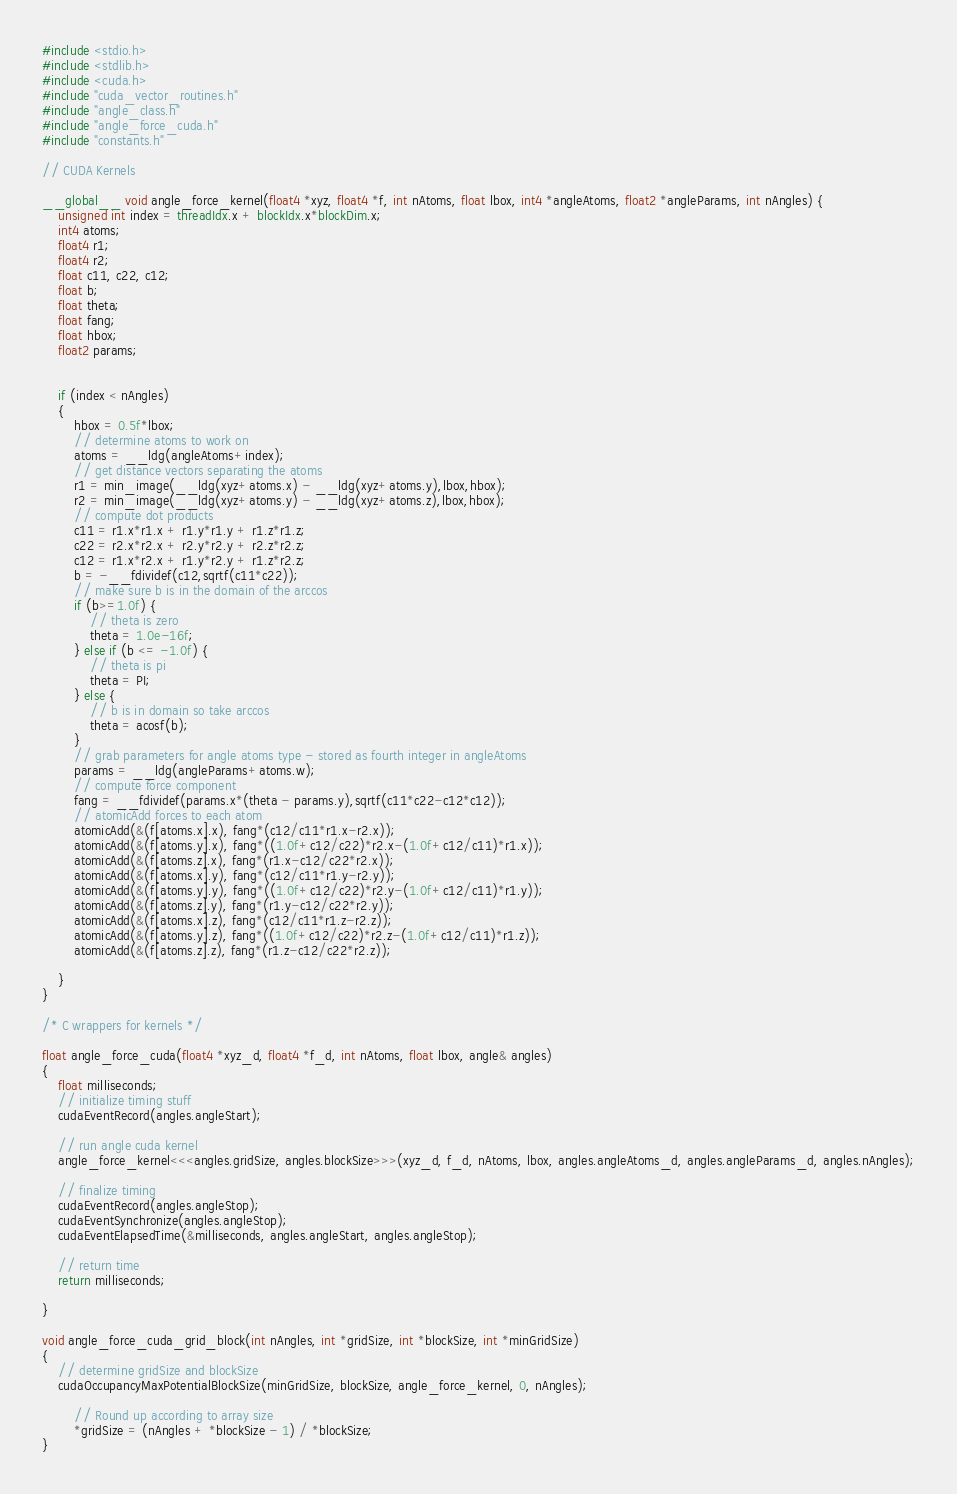Convert code to text. <code><loc_0><loc_0><loc_500><loc_500><_Cuda_>
#include <stdio.h>
#include <stdlib.h>
#include <cuda.h>
#include "cuda_vector_routines.h"
#include "angle_class.h"
#include "angle_force_cuda.h"
#include "constants.h"

// CUDA Kernels

__global__ void angle_force_kernel(float4 *xyz, float4 *f, int nAtoms, float lbox, int4 *angleAtoms, float2 *angleParams, int nAngles) {
	unsigned int index = threadIdx.x + blockIdx.x*blockDim.x;
	int4 atoms;
	float4 r1;
	float4 r2;
	float c11, c22, c12;
	float b;
	float theta;
	float fang;
	float hbox;
	float2 params;
	

	if (index < nAngles)
	{
		hbox = 0.5f*lbox;
		// determine atoms to work on
		atoms = __ldg(angleAtoms+index);
		// get distance vectors separating the atoms
		r1 = min_image(__ldg(xyz+atoms.x) - __ldg(xyz+atoms.y),lbox,hbox);
		r2 = min_image(__ldg(xyz+atoms.y) - __ldg(xyz+atoms.z),lbox,hbox);
		// compute dot products
		c11 = r1.x*r1.x + r1.y*r1.y + r1.z*r1.z;
		c22 = r2.x*r2.x + r2.y*r2.y + r2.z*r2.z;
		c12 = r1.x*r2.x + r1.y*r2.y + r1.z*r2.z;
		b = -__fdividef(c12,sqrtf(c11*c22));
		// make sure b is in the domain of the arccos
		if (b>=1.0f) {
			// theta is zero
			theta = 1.0e-16f;
		} else if (b <= -1.0f) {
			// theta is pi
			theta = PI;
		} else {
			// b is in domain so take arccos
			theta = acosf(b);
		}
		// grab parameters for angle atoms type - stored as fourth integer in angleAtoms
		params = __ldg(angleParams+atoms.w);
		// compute force component
		fang = __fdividef(params.x*(theta - params.y),sqrtf(c11*c22-c12*c12));
		// atomicAdd forces to each atom
		atomicAdd(&(f[atoms.x].x), fang*(c12/c11*r1.x-r2.x));
		atomicAdd(&(f[atoms.y].x), fang*((1.0f+c12/c22)*r2.x-(1.0f+c12/c11)*r1.x));
		atomicAdd(&(f[atoms.z].x), fang*(r1.x-c12/c22*r2.x));
		atomicAdd(&(f[atoms.x].y), fang*(c12/c11*r1.y-r2.y));
		atomicAdd(&(f[atoms.y].y), fang*((1.0f+c12/c22)*r2.y-(1.0f+c12/c11)*r1.y));
		atomicAdd(&(f[atoms.z].y), fang*(r1.y-c12/c22*r2.y));
		atomicAdd(&(f[atoms.x].z), fang*(c12/c11*r1.z-r2.z));
		atomicAdd(&(f[atoms.y].z), fang*((1.0f+c12/c22)*r2.z-(1.0f+c12/c11)*r1.z));
		atomicAdd(&(f[atoms.z].z), fang*(r1.z-c12/c22*r2.z));

	}
}

/* C wrappers for kernels */

float angle_force_cuda(float4 *xyz_d, float4 *f_d, int nAtoms, float lbox, angle& angles) 
{
	float milliseconds;
	// initialize timing stuff
	cudaEventRecord(angles.angleStart);
	
	// run angle cuda kernel
	angle_force_kernel<<<angles.gridSize, angles.blockSize>>>(xyz_d, f_d, nAtoms, lbox, angles.angleAtoms_d, angles.angleParams_d, angles.nAngles);

	// finalize timing
	cudaEventRecord(angles.angleStop);
	cudaEventSynchronize(angles.angleStop);
	cudaEventElapsedTime(&milliseconds, angles.angleStart, angles.angleStop);

	// return time
	return milliseconds;

}

void angle_force_cuda_grid_block(int nAngles, int *gridSize, int *blockSize, int *minGridSize)
{
	// determine gridSize and blockSize
	cudaOccupancyMaxPotentialBlockSize(minGridSize, blockSize, angle_force_kernel, 0, nAngles); 

    	// Round up according to array size 
    	*gridSize = (nAngles + *blockSize - 1) / *blockSize; 
}
</code> 